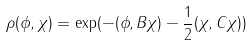Convert formula to latex. <formula><loc_0><loc_0><loc_500><loc_500>\rho ( \phi , \chi ) = \exp ( - ( \phi , B \chi ) - \frac { 1 } { 2 } ( \chi , C \chi ) )</formula> 